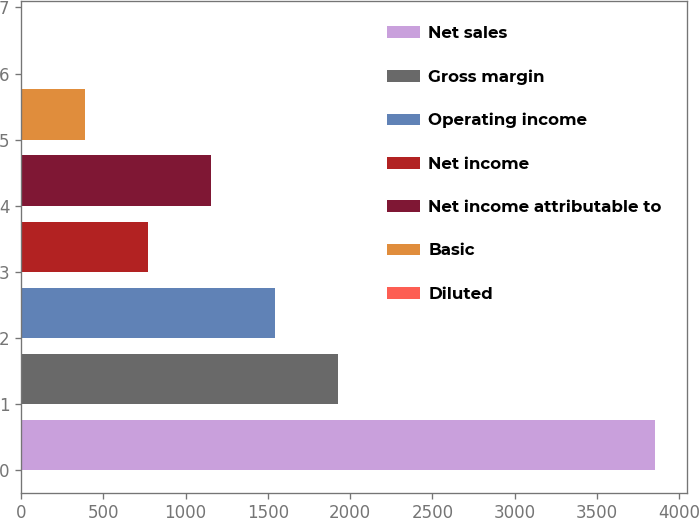<chart> <loc_0><loc_0><loc_500><loc_500><bar_chart><fcel>Net sales<fcel>Gross margin<fcel>Operating income<fcel>Net income<fcel>Net income attributable to<fcel>Basic<fcel>Diluted<nl><fcel>3853<fcel>1926.72<fcel>1541.46<fcel>770.94<fcel>1156.2<fcel>385.68<fcel>0.42<nl></chart> 